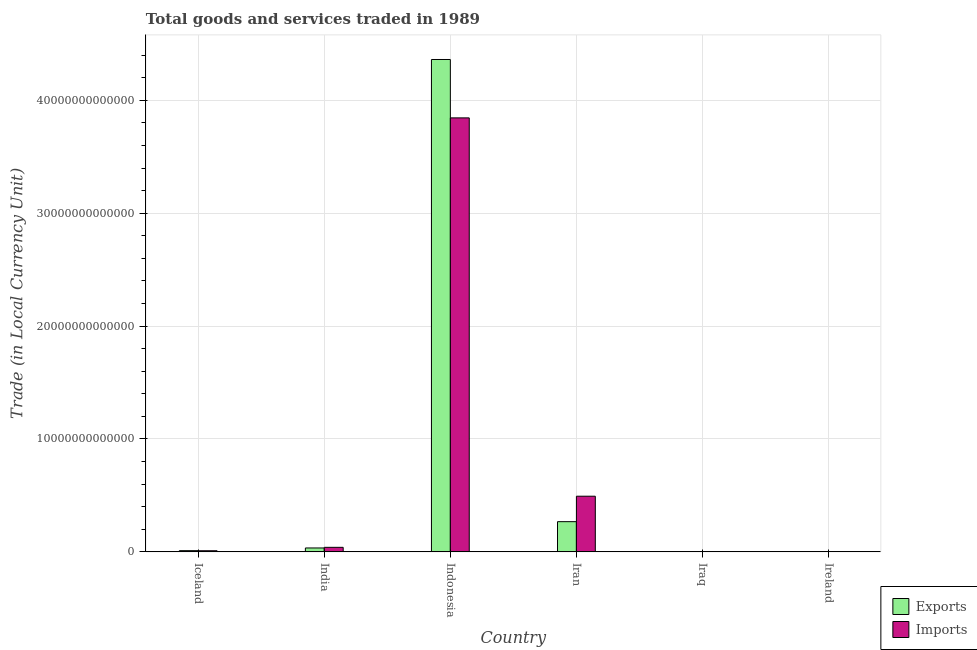How many different coloured bars are there?
Offer a terse response. 2. Are the number of bars on each tick of the X-axis equal?
Ensure brevity in your answer.  Yes. How many bars are there on the 2nd tick from the left?
Provide a short and direct response. 2. How many bars are there on the 6th tick from the right?
Give a very brief answer. 2. What is the label of the 6th group of bars from the left?
Offer a very short reply. Ireland. What is the imports of goods and services in Iraq?
Keep it short and to the point. 4.67e+09. Across all countries, what is the maximum export of goods and services?
Your answer should be compact. 4.36e+13. Across all countries, what is the minimum export of goods and services?
Your answer should be very brief. 4.48e+09. In which country was the imports of goods and services maximum?
Your response must be concise. Indonesia. In which country was the imports of goods and services minimum?
Offer a terse response. Iraq. What is the total imports of goods and services in the graph?
Your answer should be very brief. 4.39e+13. What is the difference between the export of goods and services in Indonesia and that in Iran?
Offer a terse response. 4.09e+13. What is the difference between the imports of goods and services in Iran and the export of goods and services in Iceland?
Provide a short and direct response. 4.82e+12. What is the average export of goods and services per country?
Ensure brevity in your answer.  7.79e+12. What is the difference between the imports of goods and services and export of goods and services in India?
Ensure brevity in your answer.  5.60e+1. In how many countries, is the imports of goods and services greater than 34000000000000 LCU?
Make the answer very short. 1. What is the ratio of the export of goods and services in Iran to that in Ireland?
Ensure brevity in your answer.  129.19. Is the imports of goods and services in India less than that in Iraq?
Your answer should be compact. No. What is the difference between the highest and the second highest imports of goods and services?
Your answer should be compact. 3.35e+13. What is the difference between the highest and the lowest imports of goods and services?
Your response must be concise. 3.84e+13. In how many countries, is the imports of goods and services greater than the average imports of goods and services taken over all countries?
Give a very brief answer. 1. Is the sum of the imports of goods and services in India and Iran greater than the maximum export of goods and services across all countries?
Give a very brief answer. No. What does the 1st bar from the left in Iceland represents?
Make the answer very short. Exports. What does the 2nd bar from the right in Iceland represents?
Your answer should be compact. Exports. How many bars are there?
Offer a terse response. 12. Are all the bars in the graph horizontal?
Provide a short and direct response. No. What is the difference between two consecutive major ticks on the Y-axis?
Ensure brevity in your answer.  1.00e+13. Are the values on the major ticks of Y-axis written in scientific E-notation?
Offer a terse response. No. Does the graph contain any zero values?
Your answer should be compact. No. Does the graph contain grids?
Your answer should be very brief. Yes. How are the legend labels stacked?
Provide a short and direct response. Vertical. What is the title of the graph?
Offer a very short reply. Total goods and services traded in 1989. Does "Drinking water services" appear as one of the legend labels in the graph?
Offer a terse response. No. What is the label or title of the X-axis?
Make the answer very short. Country. What is the label or title of the Y-axis?
Your response must be concise. Trade (in Local Currency Unit). What is the Trade (in Local Currency Unit) in Exports in Iceland?
Offer a very short reply. 1.07e+11. What is the Trade (in Local Currency Unit) in Imports in Iceland?
Offer a terse response. 9.98e+1. What is the Trade (in Local Currency Unit) in Exports in India?
Your answer should be very brief. 3.46e+11. What is the Trade (in Local Currency Unit) in Imports in India?
Provide a short and direct response. 4.02e+11. What is the Trade (in Local Currency Unit) of Exports in Indonesia?
Ensure brevity in your answer.  4.36e+13. What is the Trade (in Local Currency Unit) of Imports in Indonesia?
Keep it short and to the point. 3.84e+13. What is the Trade (in Local Currency Unit) of Exports in Iran?
Provide a short and direct response. 2.68e+12. What is the Trade (in Local Currency Unit) of Imports in Iran?
Ensure brevity in your answer.  4.93e+12. What is the Trade (in Local Currency Unit) of Exports in Iraq?
Your answer should be compact. 4.48e+09. What is the Trade (in Local Currency Unit) of Imports in Iraq?
Your answer should be very brief. 4.67e+09. What is the Trade (in Local Currency Unit) of Exports in Ireland?
Provide a succinct answer. 2.07e+1. What is the Trade (in Local Currency Unit) in Imports in Ireland?
Your answer should be compact. 1.88e+1. Across all countries, what is the maximum Trade (in Local Currency Unit) of Exports?
Offer a terse response. 4.36e+13. Across all countries, what is the maximum Trade (in Local Currency Unit) in Imports?
Ensure brevity in your answer.  3.84e+13. Across all countries, what is the minimum Trade (in Local Currency Unit) of Exports?
Give a very brief answer. 4.48e+09. Across all countries, what is the minimum Trade (in Local Currency Unit) of Imports?
Keep it short and to the point. 4.67e+09. What is the total Trade (in Local Currency Unit) of Exports in the graph?
Your answer should be compact. 4.68e+13. What is the total Trade (in Local Currency Unit) in Imports in the graph?
Your answer should be compact. 4.39e+13. What is the difference between the Trade (in Local Currency Unit) of Exports in Iceland and that in India?
Ensure brevity in your answer.  -2.39e+11. What is the difference between the Trade (in Local Currency Unit) of Imports in Iceland and that in India?
Give a very brief answer. -3.02e+11. What is the difference between the Trade (in Local Currency Unit) in Exports in Iceland and that in Indonesia?
Keep it short and to the point. -4.35e+13. What is the difference between the Trade (in Local Currency Unit) in Imports in Iceland and that in Indonesia?
Your answer should be very brief. -3.83e+13. What is the difference between the Trade (in Local Currency Unit) in Exports in Iceland and that in Iran?
Provide a short and direct response. -2.57e+12. What is the difference between the Trade (in Local Currency Unit) of Imports in Iceland and that in Iran?
Your answer should be very brief. -4.83e+12. What is the difference between the Trade (in Local Currency Unit) of Exports in Iceland and that in Iraq?
Your answer should be compact. 1.02e+11. What is the difference between the Trade (in Local Currency Unit) in Imports in Iceland and that in Iraq?
Your answer should be compact. 9.52e+1. What is the difference between the Trade (in Local Currency Unit) in Exports in Iceland and that in Ireland?
Provide a succinct answer. 8.62e+1. What is the difference between the Trade (in Local Currency Unit) in Imports in Iceland and that in Ireland?
Give a very brief answer. 8.10e+1. What is the difference between the Trade (in Local Currency Unit) of Exports in India and that in Indonesia?
Make the answer very short. -4.33e+13. What is the difference between the Trade (in Local Currency Unit) of Imports in India and that in Indonesia?
Offer a very short reply. -3.80e+13. What is the difference between the Trade (in Local Currency Unit) in Exports in India and that in Iran?
Keep it short and to the point. -2.33e+12. What is the difference between the Trade (in Local Currency Unit) in Imports in India and that in Iran?
Your answer should be very brief. -4.53e+12. What is the difference between the Trade (in Local Currency Unit) of Exports in India and that in Iraq?
Make the answer very short. 3.42e+11. What is the difference between the Trade (in Local Currency Unit) in Imports in India and that in Iraq?
Make the answer very short. 3.97e+11. What is the difference between the Trade (in Local Currency Unit) of Exports in India and that in Ireland?
Give a very brief answer. 3.25e+11. What is the difference between the Trade (in Local Currency Unit) of Imports in India and that in Ireland?
Offer a very short reply. 3.83e+11. What is the difference between the Trade (in Local Currency Unit) in Exports in Indonesia and that in Iran?
Keep it short and to the point. 4.09e+13. What is the difference between the Trade (in Local Currency Unit) in Imports in Indonesia and that in Iran?
Provide a short and direct response. 3.35e+13. What is the difference between the Trade (in Local Currency Unit) of Exports in Indonesia and that in Iraq?
Offer a terse response. 4.36e+13. What is the difference between the Trade (in Local Currency Unit) in Imports in Indonesia and that in Iraq?
Offer a terse response. 3.84e+13. What is the difference between the Trade (in Local Currency Unit) of Exports in Indonesia and that in Ireland?
Ensure brevity in your answer.  4.36e+13. What is the difference between the Trade (in Local Currency Unit) in Imports in Indonesia and that in Ireland?
Offer a very short reply. 3.84e+13. What is the difference between the Trade (in Local Currency Unit) in Exports in Iran and that in Iraq?
Your response must be concise. 2.67e+12. What is the difference between the Trade (in Local Currency Unit) of Imports in Iran and that in Iraq?
Give a very brief answer. 4.93e+12. What is the difference between the Trade (in Local Currency Unit) of Exports in Iran and that in Ireland?
Keep it short and to the point. 2.66e+12. What is the difference between the Trade (in Local Currency Unit) in Imports in Iran and that in Ireland?
Offer a very short reply. 4.91e+12. What is the difference between the Trade (in Local Currency Unit) in Exports in Iraq and that in Ireland?
Give a very brief answer. -1.62e+1. What is the difference between the Trade (in Local Currency Unit) of Imports in Iraq and that in Ireland?
Provide a short and direct response. -1.42e+1. What is the difference between the Trade (in Local Currency Unit) in Exports in Iceland and the Trade (in Local Currency Unit) in Imports in India?
Keep it short and to the point. -2.95e+11. What is the difference between the Trade (in Local Currency Unit) of Exports in Iceland and the Trade (in Local Currency Unit) of Imports in Indonesia?
Offer a very short reply. -3.83e+13. What is the difference between the Trade (in Local Currency Unit) of Exports in Iceland and the Trade (in Local Currency Unit) of Imports in Iran?
Offer a very short reply. -4.82e+12. What is the difference between the Trade (in Local Currency Unit) in Exports in Iceland and the Trade (in Local Currency Unit) in Imports in Iraq?
Give a very brief answer. 1.02e+11. What is the difference between the Trade (in Local Currency Unit) of Exports in Iceland and the Trade (in Local Currency Unit) of Imports in Ireland?
Make the answer very short. 8.81e+1. What is the difference between the Trade (in Local Currency Unit) of Exports in India and the Trade (in Local Currency Unit) of Imports in Indonesia?
Provide a succinct answer. -3.81e+13. What is the difference between the Trade (in Local Currency Unit) in Exports in India and the Trade (in Local Currency Unit) in Imports in Iran?
Give a very brief answer. -4.59e+12. What is the difference between the Trade (in Local Currency Unit) in Exports in India and the Trade (in Local Currency Unit) in Imports in Iraq?
Your answer should be very brief. 3.41e+11. What is the difference between the Trade (in Local Currency Unit) of Exports in India and the Trade (in Local Currency Unit) of Imports in Ireland?
Provide a succinct answer. 3.27e+11. What is the difference between the Trade (in Local Currency Unit) of Exports in Indonesia and the Trade (in Local Currency Unit) of Imports in Iran?
Provide a short and direct response. 3.87e+13. What is the difference between the Trade (in Local Currency Unit) in Exports in Indonesia and the Trade (in Local Currency Unit) in Imports in Iraq?
Provide a succinct answer. 4.36e+13. What is the difference between the Trade (in Local Currency Unit) of Exports in Indonesia and the Trade (in Local Currency Unit) of Imports in Ireland?
Your answer should be compact. 4.36e+13. What is the difference between the Trade (in Local Currency Unit) in Exports in Iran and the Trade (in Local Currency Unit) in Imports in Iraq?
Provide a short and direct response. 2.67e+12. What is the difference between the Trade (in Local Currency Unit) in Exports in Iran and the Trade (in Local Currency Unit) in Imports in Ireland?
Keep it short and to the point. 2.66e+12. What is the difference between the Trade (in Local Currency Unit) in Exports in Iraq and the Trade (in Local Currency Unit) in Imports in Ireland?
Your response must be concise. -1.43e+1. What is the average Trade (in Local Currency Unit) of Exports per country?
Give a very brief answer. 7.79e+12. What is the average Trade (in Local Currency Unit) in Imports per country?
Keep it short and to the point. 7.32e+12. What is the difference between the Trade (in Local Currency Unit) in Exports and Trade (in Local Currency Unit) in Imports in Iceland?
Ensure brevity in your answer.  7.05e+09. What is the difference between the Trade (in Local Currency Unit) of Exports and Trade (in Local Currency Unit) of Imports in India?
Provide a short and direct response. -5.60e+1. What is the difference between the Trade (in Local Currency Unit) of Exports and Trade (in Local Currency Unit) of Imports in Indonesia?
Offer a very short reply. 5.17e+12. What is the difference between the Trade (in Local Currency Unit) in Exports and Trade (in Local Currency Unit) in Imports in Iran?
Your answer should be compact. -2.25e+12. What is the difference between the Trade (in Local Currency Unit) of Exports and Trade (in Local Currency Unit) of Imports in Iraq?
Your response must be concise. -1.85e+08. What is the difference between the Trade (in Local Currency Unit) in Exports and Trade (in Local Currency Unit) in Imports in Ireland?
Keep it short and to the point. 1.90e+09. What is the ratio of the Trade (in Local Currency Unit) of Exports in Iceland to that in India?
Make the answer very short. 0.31. What is the ratio of the Trade (in Local Currency Unit) of Imports in Iceland to that in India?
Provide a succinct answer. 0.25. What is the ratio of the Trade (in Local Currency Unit) in Exports in Iceland to that in Indonesia?
Provide a succinct answer. 0. What is the ratio of the Trade (in Local Currency Unit) of Imports in Iceland to that in Indonesia?
Ensure brevity in your answer.  0. What is the ratio of the Trade (in Local Currency Unit) of Exports in Iceland to that in Iran?
Your answer should be very brief. 0.04. What is the ratio of the Trade (in Local Currency Unit) of Imports in Iceland to that in Iran?
Provide a short and direct response. 0.02. What is the ratio of the Trade (in Local Currency Unit) in Exports in Iceland to that in Iraq?
Your answer should be compact. 23.85. What is the ratio of the Trade (in Local Currency Unit) of Imports in Iceland to that in Iraq?
Keep it short and to the point. 21.39. What is the ratio of the Trade (in Local Currency Unit) of Exports in Iceland to that in Ireland?
Ensure brevity in your answer.  5.16. What is the ratio of the Trade (in Local Currency Unit) of Imports in Iceland to that in Ireland?
Give a very brief answer. 5.31. What is the ratio of the Trade (in Local Currency Unit) of Exports in India to that in Indonesia?
Keep it short and to the point. 0.01. What is the ratio of the Trade (in Local Currency Unit) of Imports in India to that in Indonesia?
Provide a succinct answer. 0.01. What is the ratio of the Trade (in Local Currency Unit) of Exports in India to that in Iran?
Ensure brevity in your answer.  0.13. What is the ratio of the Trade (in Local Currency Unit) in Imports in India to that in Iran?
Provide a short and direct response. 0.08. What is the ratio of the Trade (in Local Currency Unit) in Exports in India to that in Iraq?
Provide a succinct answer. 77.21. What is the ratio of the Trade (in Local Currency Unit) in Imports in India to that in Iraq?
Offer a very short reply. 86.16. What is the ratio of the Trade (in Local Currency Unit) of Exports in India to that in Ireland?
Provide a short and direct response. 16.71. What is the ratio of the Trade (in Local Currency Unit) of Imports in India to that in Ireland?
Provide a short and direct response. 21.37. What is the ratio of the Trade (in Local Currency Unit) in Exports in Indonesia to that in Iran?
Give a very brief answer. 16.3. What is the ratio of the Trade (in Local Currency Unit) of Imports in Indonesia to that in Iran?
Make the answer very short. 7.8. What is the ratio of the Trade (in Local Currency Unit) in Exports in Indonesia to that in Iraq?
Offer a very short reply. 9729.71. What is the ratio of the Trade (in Local Currency Unit) of Imports in Indonesia to that in Iraq?
Make the answer very short. 8236.67. What is the ratio of the Trade (in Local Currency Unit) in Exports in Indonesia to that in Ireland?
Your response must be concise. 2105.4. What is the ratio of the Trade (in Local Currency Unit) of Imports in Indonesia to that in Ireland?
Your answer should be compact. 2042.64. What is the ratio of the Trade (in Local Currency Unit) of Exports in Iran to that in Iraq?
Your response must be concise. 597.01. What is the ratio of the Trade (in Local Currency Unit) of Imports in Iran to that in Iraq?
Your answer should be compact. 1056.53. What is the ratio of the Trade (in Local Currency Unit) of Exports in Iran to that in Ireland?
Ensure brevity in your answer.  129.19. What is the ratio of the Trade (in Local Currency Unit) in Imports in Iran to that in Ireland?
Offer a very short reply. 262.01. What is the ratio of the Trade (in Local Currency Unit) in Exports in Iraq to that in Ireland?
Offer a terse response. 0.22. What is the ratio of the Trade (in Local Currency Unit) of Imports in Iraq to that in Ireland?
Offer a terse response. 0.25. What is the difference between the highest and the second highest Trade (in Local Currency Unit) of Exports?
Ensure brevity in your answer.  4.09e+13. What is the difference between the highest and the second highest Trade (in Local Currency Unit) of Imports?
Offer a terse response. 3.35e+13. What is the difference between the highest and the lowest Trade (in Local Currency Unit) in Exports?
Give a very brief answer. 4.36e+13. What is the difference between the highest and the lowest Trade (in Local Currency Unit) of Imports?
Your response must be concise. 3.84e+13. 